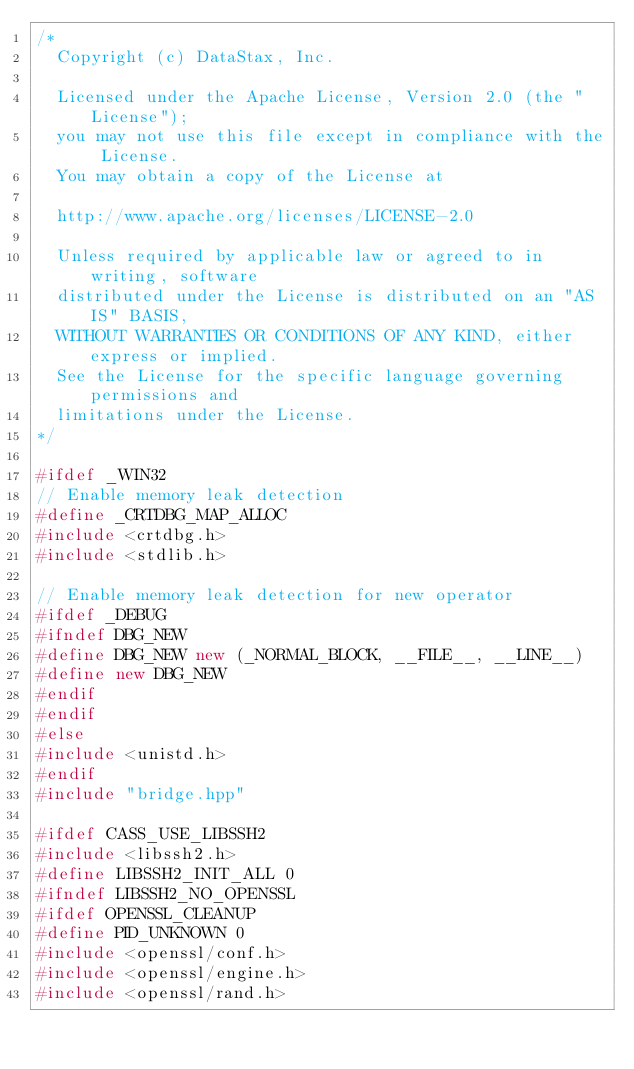<code> <loc_0><loc_0><loc_500><loc_500><_C++_>/*
  Copyright (c) DataStax, Inc.

  Licensed under the Apache License, Version 2.0 (the "License");
  you may not use this file except in compliance with the License.
  You may obtain a copy of the License at

  http://www.apache.org/licenses/LICENSE-2.0

  Unless required by applicable law or agreed to in writing, software
  distributed under the License is distributed on an "AS IS" BASIS,
  WITHOUT WARRANTIES OR CONDITIONS OF ANY KIND, either express or implied.
  See the License for the specific language governing permissions and
  limitations under the License.
*/

#ifdef _WIN32
// Enable memory leak detection
#define _CRTDBG_MAP_ALLOC
#include <crtdbg.h>
#include <stdlib.h>

// Enable memory leak detection for new operator
#ifdef _DEBUG
#ifndef DBG_NEW
#define DBG_NEW new (_NORMAL_BLOCK, __FILE__, __LINE__)
#define new DBG_NEW
#endif
#endif
#else
#include <unistd.h>
#endif
#include "bridge.hpp"

#ifdef CASS_USE_LIBSSH2
#include <libssh2.h>
#define LIBSSH2_INIT_ALL 0
#ifndef LIBSSH2_NO_OPENSSL
#ifdef OPENSSL_CLEANUP
#define PID_UNKNOWN 0
#include <openssl/conf.h>
#include <openssl/engine.h>
#include <openssl/rand.h></code> 